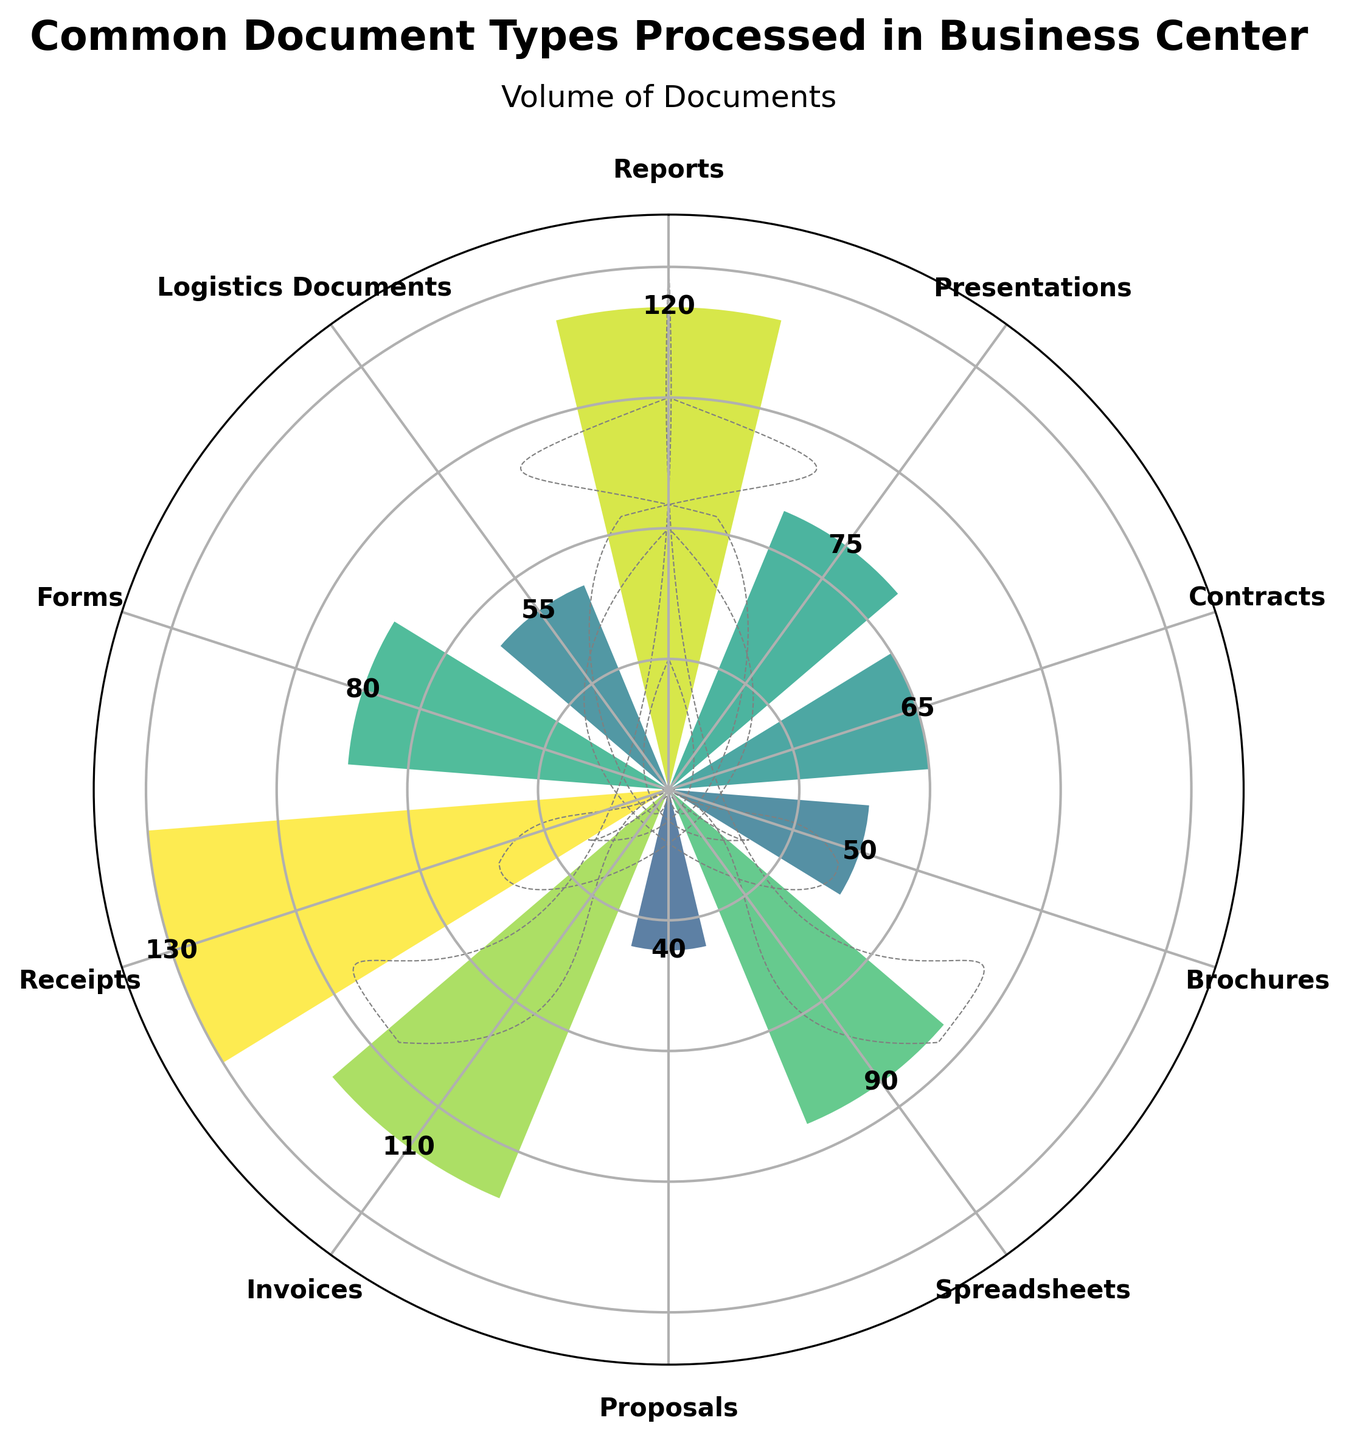What's the title of the plot? The title is displayed at the top of the plot. It reads "Common Document Types Processed in Business Center"
Answer: Common Document Types Processed in Business Center How many different document types are represented in the plot? Each document type is labeled around the plot. Counting all the labeled segments, there are 10 document types represented.
Answer: 10 Which document type has the highest volume processed? The length of the bar corresponding to each document type indicates its volume. The bar for "Receipts" is the longest, so it has the highest volume.
Answer: Receipts What is the volume of presentations processed in the business center? The bar labeled "Presentations" has a value displayed on it. Reading the value, it shows 75.
Answer: 75 What's the range of document volumes, from the lowest to the highest? The shortest bar corresponds to the smallest volume, which is 40 for Proposals, and the longest bar corresponds to the largest volume, which is 130 for Receipts. So, the range is from 40 to 130.
Answer: 40 to 130 Which two document types have volumes that differ by exactly 10? Compare the lengths and corresponding values of the bars. Reports (120) and Invoices (110) differ by exactly 10.
Answer: Reports and Invoices How does the volume of brochures compare to the volume of logistics documents? Comparing the lengths of the bars for Brochures (50) and Logistics Documents (55), Logistics Documents are slightly longer, indicating a higher volume.
Answer: Logistics Documents have a higher volume than Brochures What is the total volume of all documents processed? Sum the volumes of all the document types: 120 (Reports) + 75 (Presentations) + 65 (Contracts) + 50 (Brochures) + 90 (Spreadsheets) + 40 (Proposals) + 110 (Invoices) + 130 (Receipts) + 80 (Forms) + 55 (Logistics Documents). The total is 815.
Answer: 815 What is the average volume of documents processed? The total volume is 815, and there are 10 document types. Dividing the total volume by the number of document types gives the average: 815 / 10 = 81.5.
Answer: 81.5 Which document type has a volume closest to the average volume of all documents processed? The average volume is 81.5. Among the data points, Forms have a volume of 80, which is closest to 81.5.
Answer: Forms 